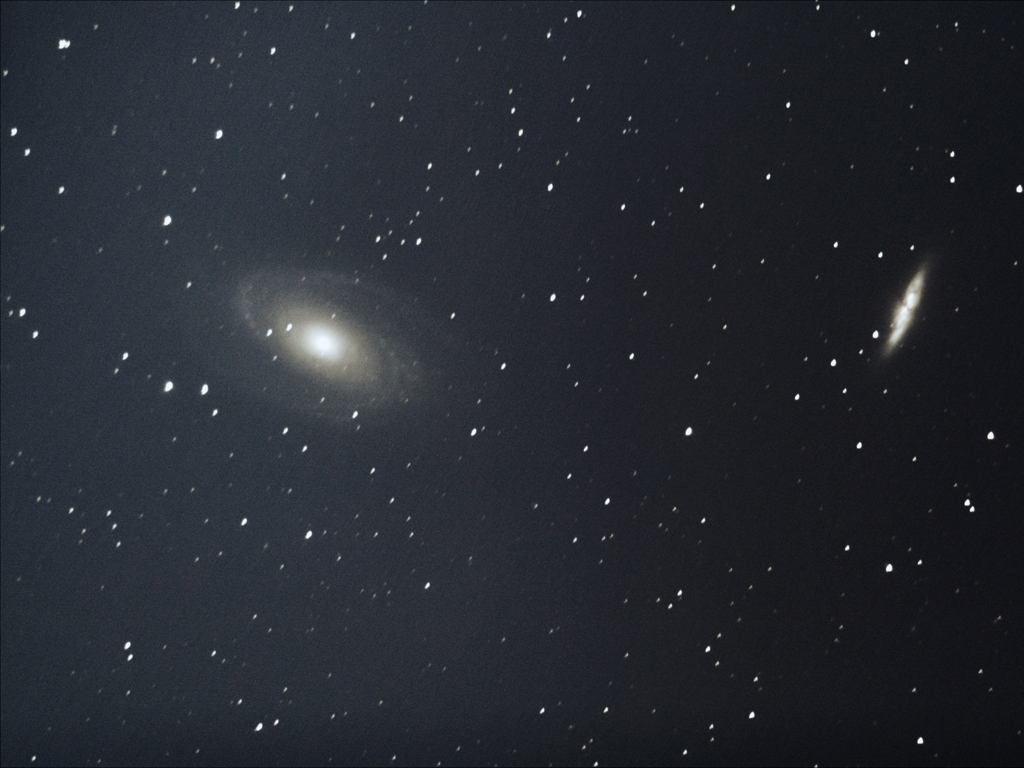Can you tell me more about the formation of the spirals in the galaxy? The spirals in a galaxy are formed by density waves that sweep through the galactic disk. These waves compress gas and dust, leading to the formation of new stars which outline the spiral pattern that we can see. How does the color of the galaxy inform us about its characteristics? The color of a galaxy can reveal information about its star population and age. Younger stars tend to be hotter and emit bluer light, while older stars emit redder light. Dust within the galaxy can also absorb more blue light, causing the galaxy to appear redder. 